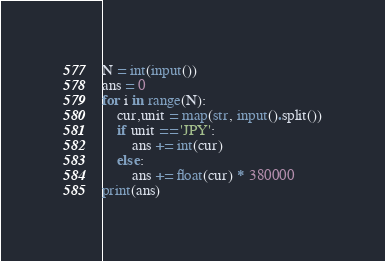<code> <loc_0><loc_0><loc_500><loc_500><_Python_>N = int(input())
ans = 0
for i in range(N):
    cur,unit = map(str, input().split())
    if unit == 'JPY':
        ans += int(cur)
    else:
        ans += float(cur) * 380000
print(ans)

</code> 